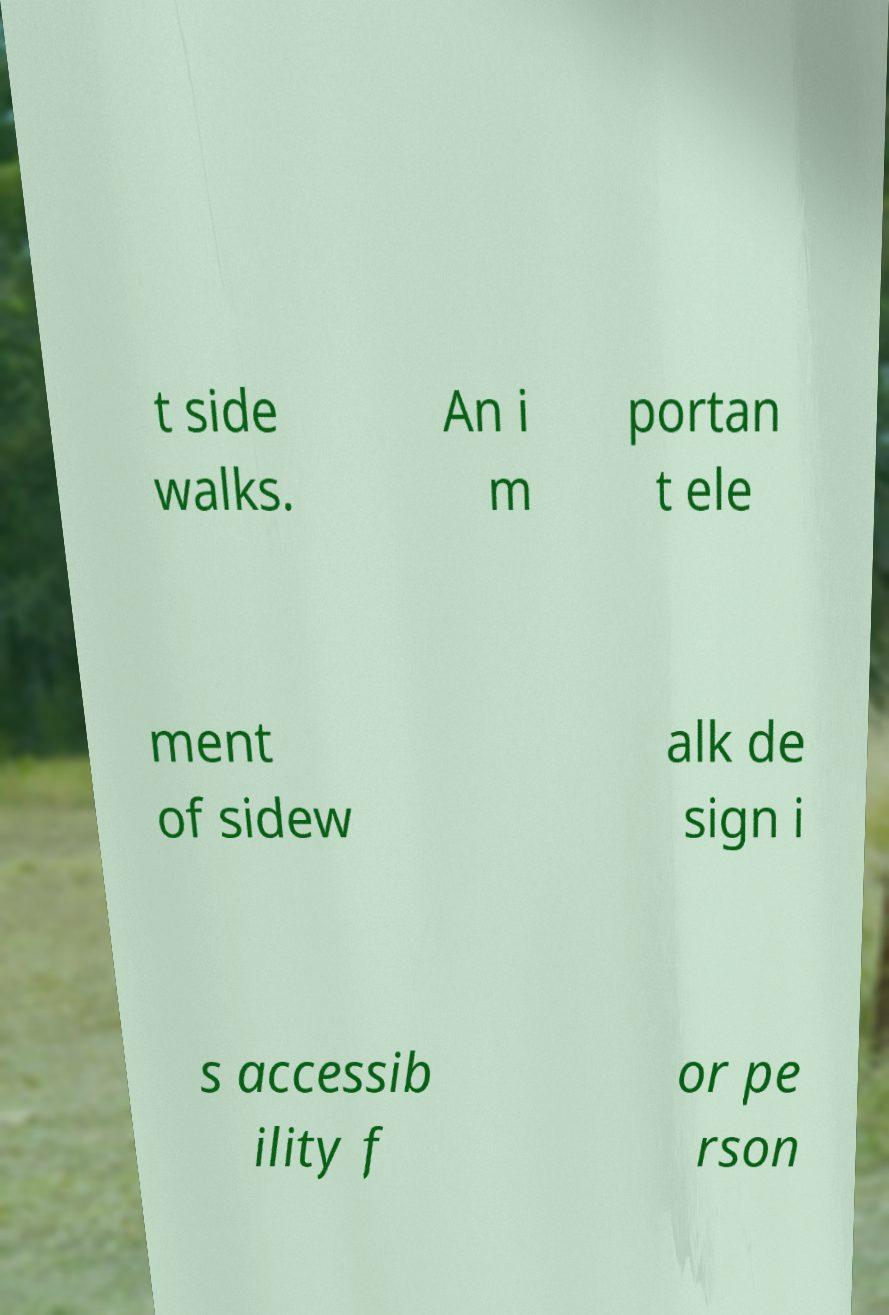Please identify and transcribe the text found in this image. t side walks. An i m portan t ele ment of sidew alk de sign i s accessib ility f or pe rson 